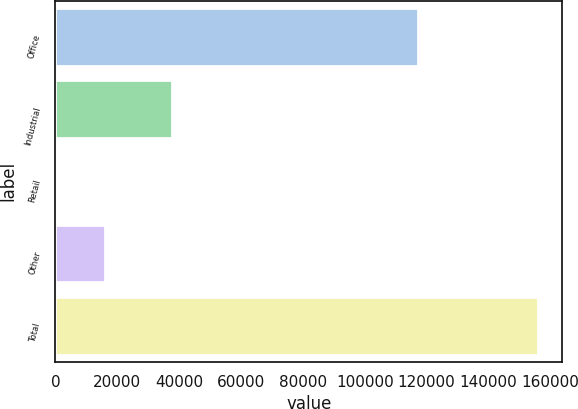Convert chart. <chart><loc_0><loc_0><loc_500><loc_500><bar_chart><fcel>Office<fcel>Industrial<fcel>Retail<fcel>Other<fcel>Total<nl><fcel>117300<fcel>37551<fcel>501<fcel>16057.9<fcel>156070<nl></chart> 